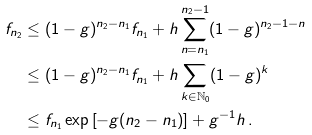<formula> <loc_0><loc_0><loc_500><loc_500>f _ { n _ { 2 } } & \leq ( 1 - g ) ^ { n _ { 2 } - n _ { 1 } } f _ { n _ { 1 } } + h \sum _ { n = n _ { 1 } } ^ { n _ { 2 } - 1 } ( 1 - g ) ^ { n _ { 2 } - 1 - n } \\ & \leq ( 1 - g ) ^ { n _ { 2 } - n _ { 1 } } f _ { n _ { 1 } } + h \sum _ { k \in \mathbb { N } _ { 0 } } ( 1 - g ) ^ { k } \\ & \leq f _ { n _ { 1 } } \exp \left [ - g ( n _ { 2 } - n _ { 1 } ) \right ] + g ^ { - 1 } h \, .</formula> 